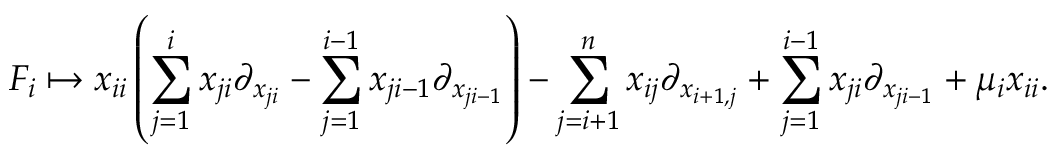Convert formula to latex. <formula><loc_0><loc_0><loc_500><loc_500>F _ { i } \mapsto x _ { i i } \left ( \sum _ { j = 1 } ^ { i } x _ { j i } \partial _ { x _ { j i } } - \sum _ { j = 1 } ^ { i - 1 } x _ { j i - 1 } \partial _ { x _ { j i - 1 } } \right ) - \sum _ { j = i + 1 } ^ { n } x _ { i j } \partial _ { x _ { i + 1 , j } } + \sum _ { j = 1 } ^ { i - 1 } x _ { j i } \partial _ { x _ { j i - 1 } } + \mu _ { i } x _ { i i } .</formula> 